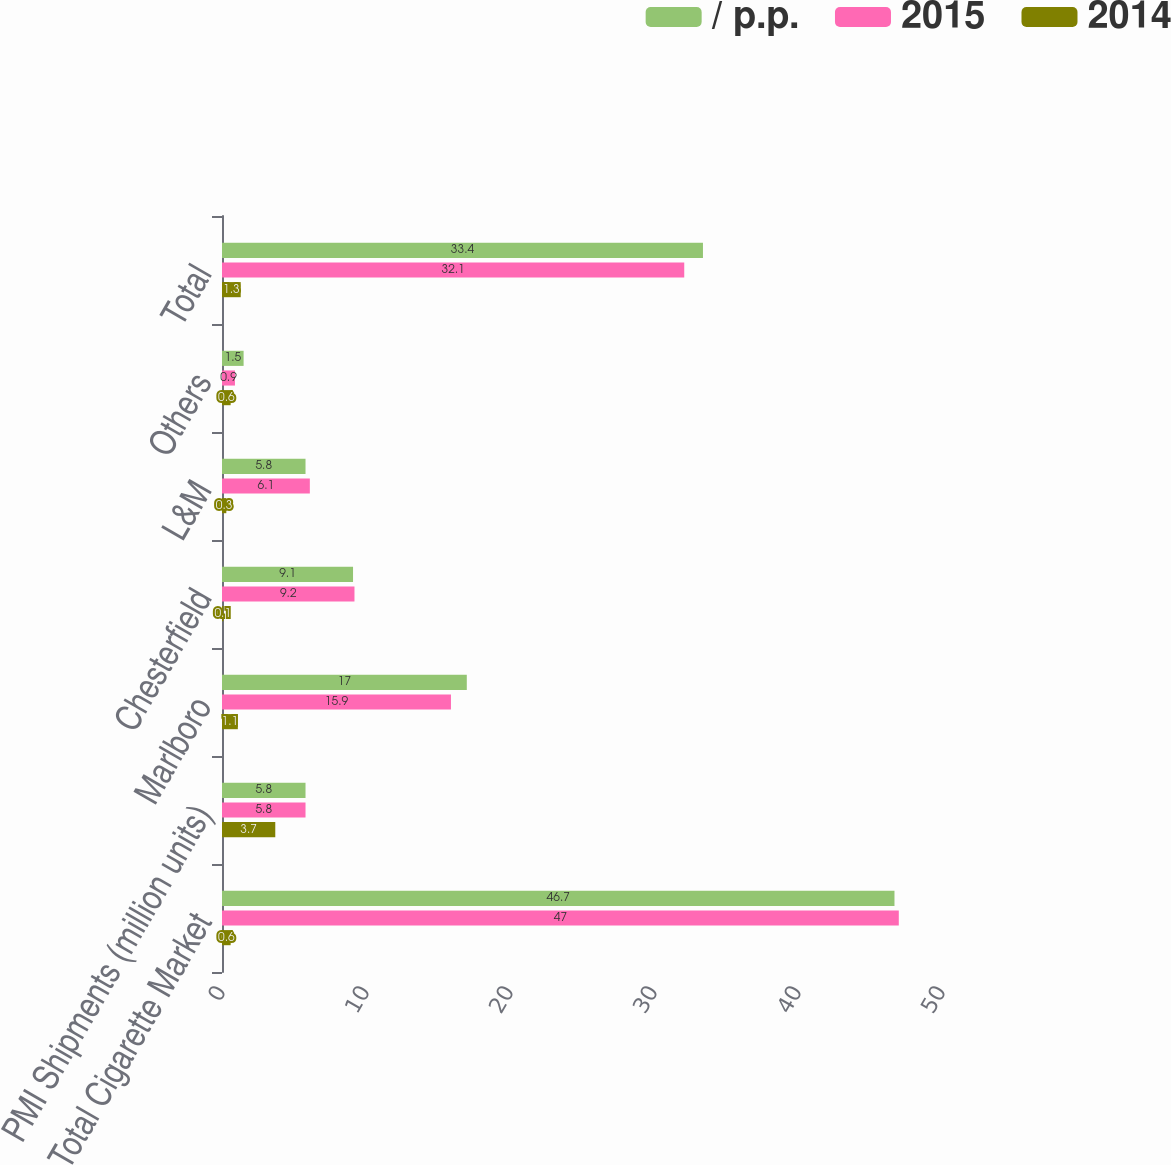<chart> <loc_0><loc_0><loc_500><loc_500><stacked_bar_chart><ecel><fcel>Total Cigarette Market<fcel>PMI Shipments (million units)<fcel>Marlboro<fcel>Chesterfield<fcel>L&M<fcel>Others<fcel>Total<nl><fcel>/ p.p.<fcel>46.7<fcel>5.8<fcel>17<fcel>9.1<fcel>5.8<fcel>1.5<fcel>33.4<nl><fcel>2015<fcel>47<fcel>5.8<fcel>15.9<fcel>9.2<fcel>6.1<fcel>0.9<fcel>32.1<nl><fcel>2014<fcel>0.6<fcel>3.7<fcel>1.1<fcel>0.1<fcel>0.3<fcel>0.6<fcel>1.3<nl></chart> 